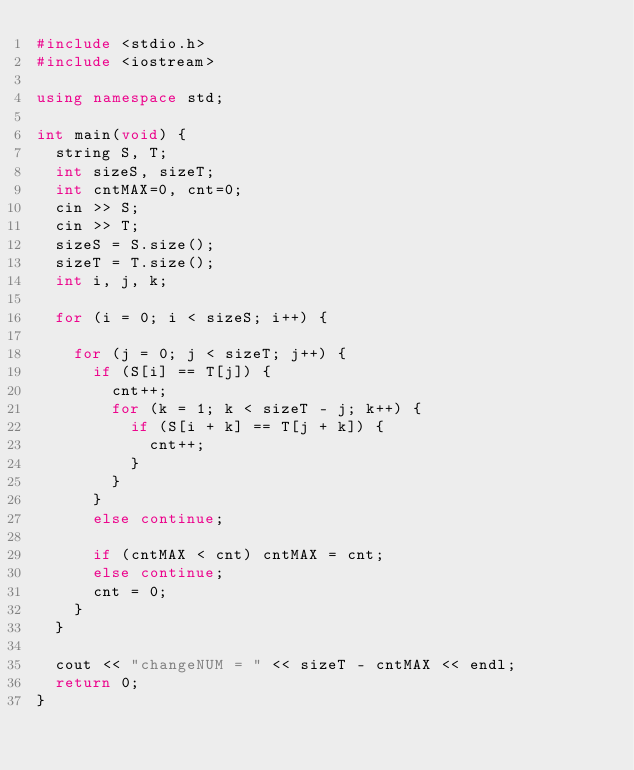<code> <loc_0><loc_0><loc_500><loc_500><_C++_>#include <stdio.h>
#include <iostream>

using namespace std;

int main(void) {
	string S, T;
	int sizeS, sizeT;
	int cntMAX=0, cnt=0;
	cin >> S;
	cin >> T;
	sizeS = S.size();
	sizeT = T.size();
	int i, j, k;

	for (i = 0; i < sizeS; i++) {

		for (j = 0; j < sizeT; j++) {
			if (S[i] == T[j]) {
				cnt++;
				for (k = 1; k < sizeT - j; k++) {
					if (S[i + k] == T[j + k]) {
						cnt++;
					}
				}
			}
			else continue;

			if (cntMAX < cnt) cntMAX = cnt;
			else continue;
			cnt = 0;
		}
	}

	cout << "changeNUM = " << sizeT - cntMAX << endl;
	return 0;
}</code> 